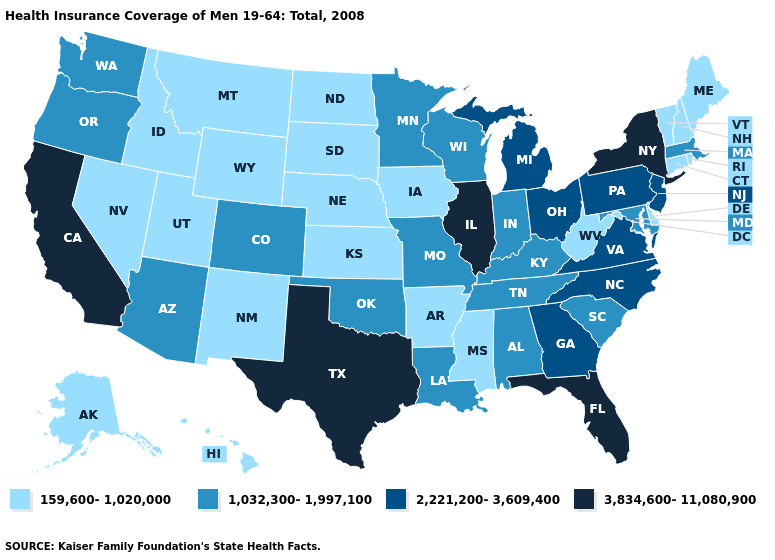What is the lowest value in the USA?
Answer briefly. 159,600-1,020,000. Does Colorado have the lowest value in the USA?
Keep it brief. No. Among the states that border California , which have the highest value?
Answer briefly. Arizona, Oregon. Name the states that have a value in the range 3,834,600-11,080,900?
Answer briefly. California, Florida, Illinois, New York, Texas. What is the value of Nevada?
Short answer required. 159,600-1,020,000. Among the states that border Louisiana , which have the highest value?
Be succinct. Texas. What is the value of Texas?
Answer briefly. 3,834,600-11,080,900. Does Texas have the highest value in the South?
Answer briefly. Yes. Does Rhode Island have the lowest value in the Northeast?
Keep it brief. Yes. Does the first symbol in the legend represent the smallest category?
Write a very short answer. Yes. What is the highest value in the Northeast ?
Short answer required. 3,834,600-11,080,900. Does Maryland have the highest value in the USA?
Concise answer only. No. Does the map have missing data?
Quick response, please. No. Among the states that border Indiana , which have the highest value?
Concise answer only. Illinois. What is the value of North Dakota?
Short answer required. 159,600-1,020,000. 